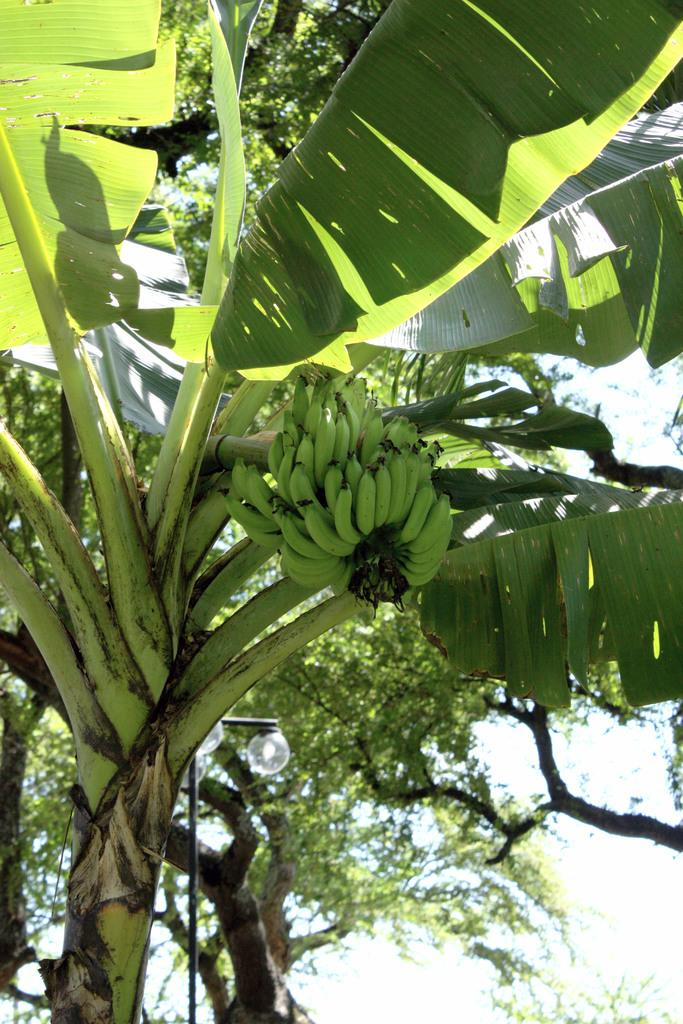What type of plant is located in the front of the image? There is a banana tree in the front of the image. What can be seen in the background of the image? There are trees in the background of the image. What type of picture is hanging on the wall in the image? There is no picture hanging on the wall in the image; it only features a banana tree and trees in the background. Can you see any fog in the image? There is no fog visible in the image. 